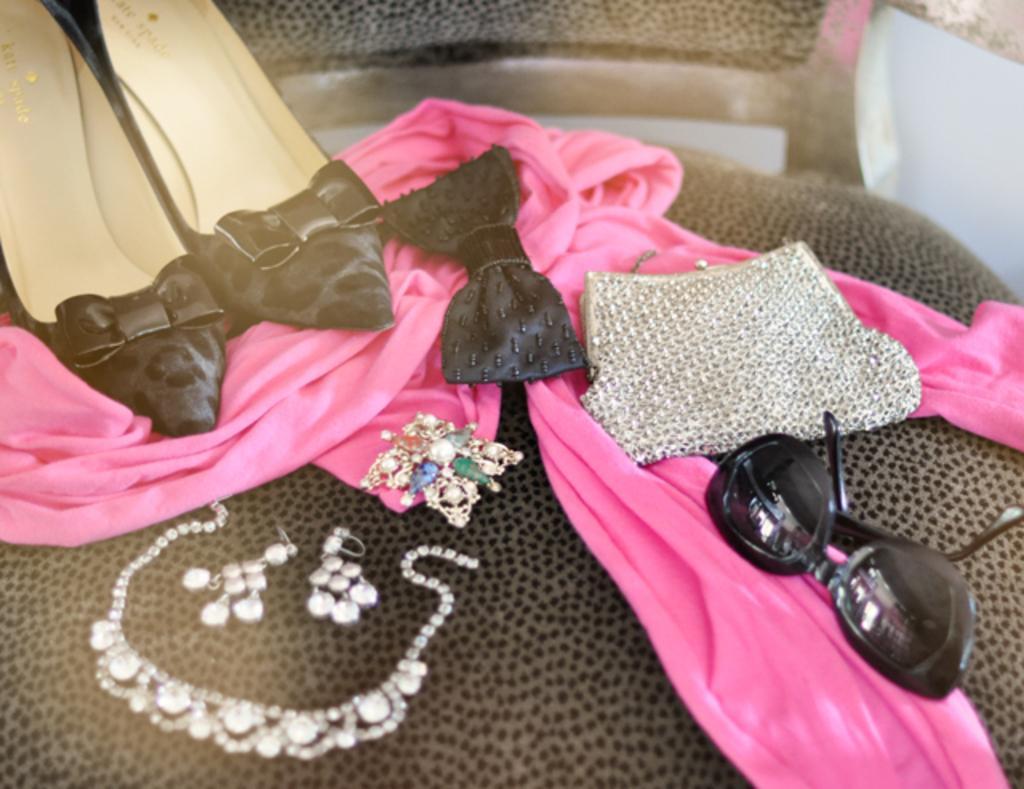Could you give a brief overview of what you see in this image? In this image, we can see a chair contains footwear, clothes, bag, jewelry and sunglasses. 